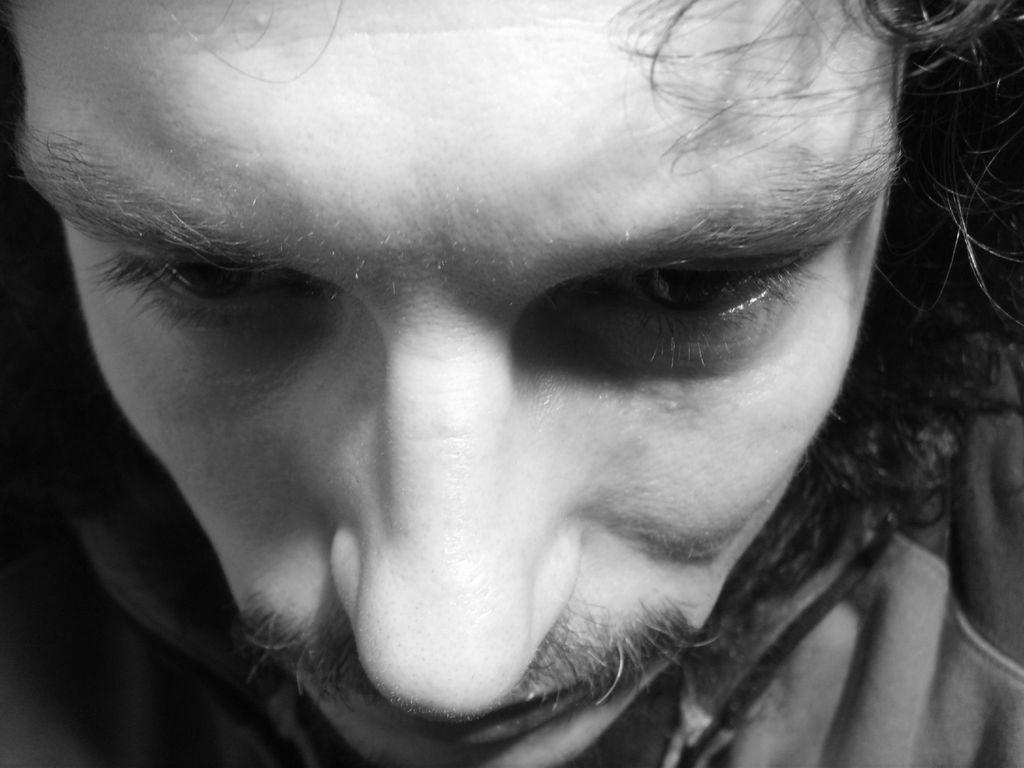In one or two sentences, can you explain what this image depicts? In this image I can see a person face and the image is in black and white. 